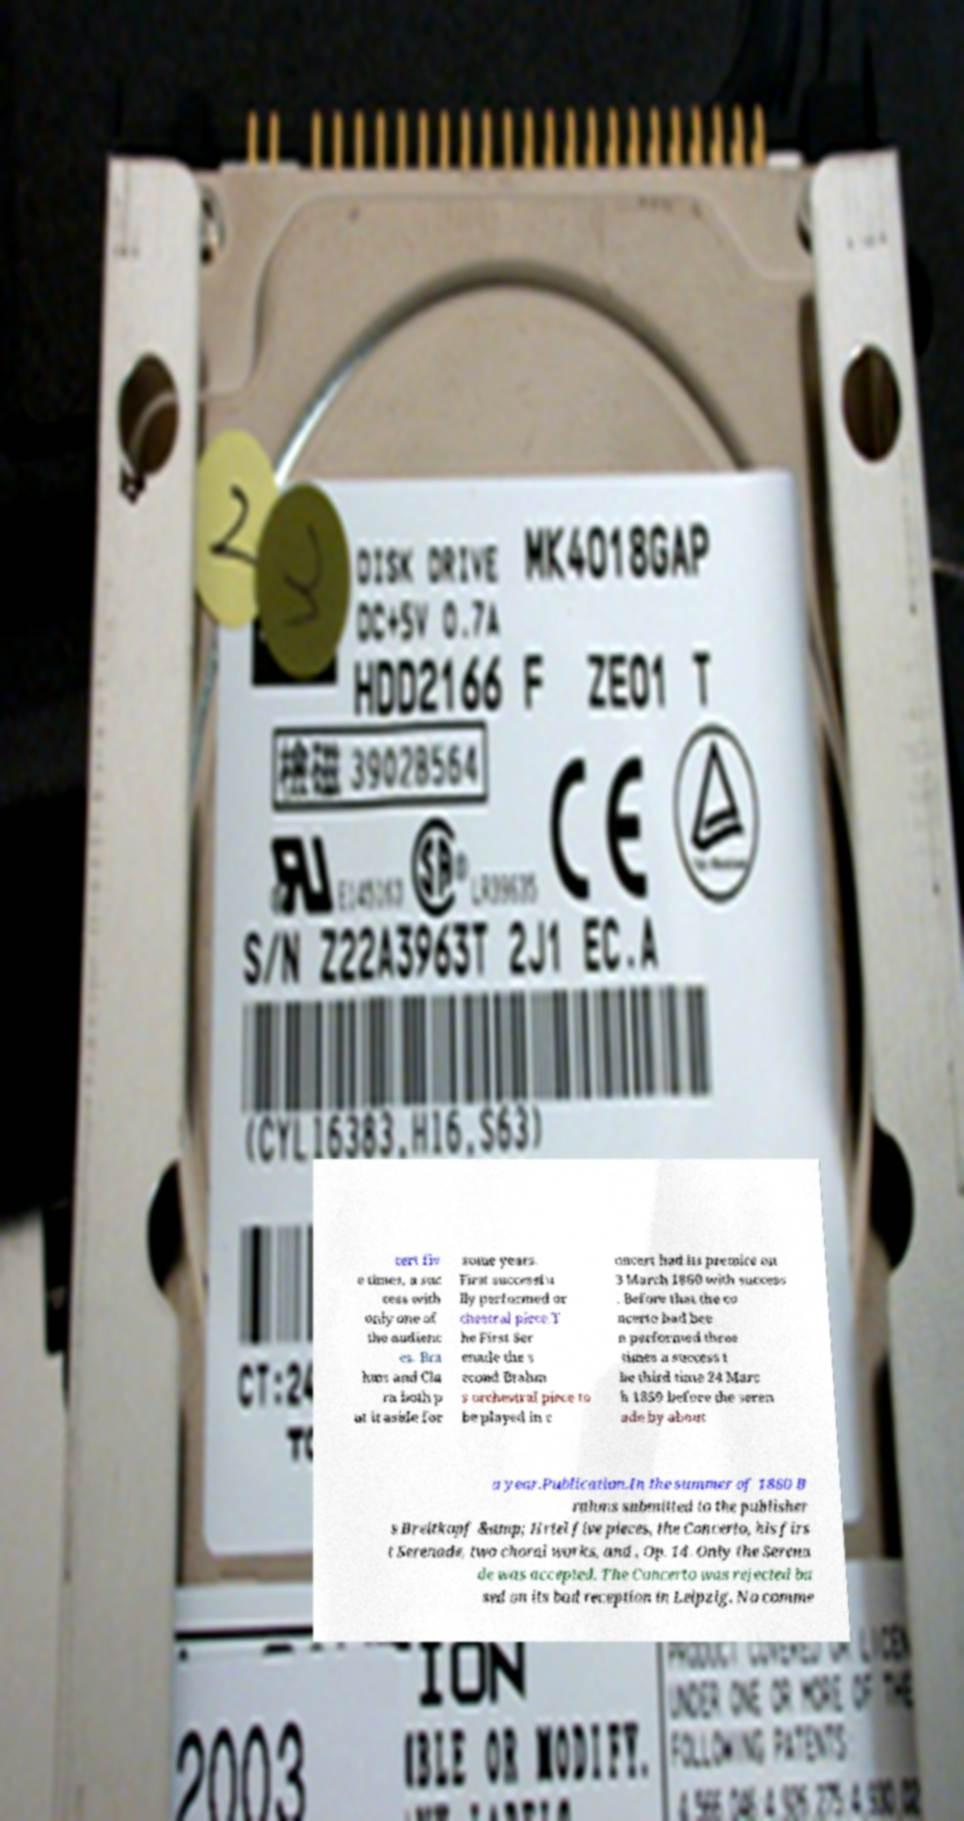Please identify and transcribe the text found in this image. cert fiv e times, a suc cess with only one of the audienc es. Bra hms and Cla ra both p ut it aside for some years. First successfu lly performed or chestral piece.T he First Ser enade the s econd Brahm s orchestral piece to be played in c oncert had its premire on 3 March 1860 with success . Before that the co ncerto had bee n performed three times a success t he third time 24 Marc h 1859 before the seren ade by about a year.Publication.In the summer of 1860 B rahms submitted to the publisher s Breitkopf &amp; Hrtel five pieces, the Concerto, his firs t Serenade, two choral works, and , Op. 14. Only the Serena de was accepted. The Concerto was rejected ba sed on its bad reception in Leipzig. No comme 